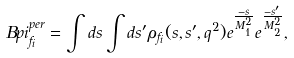<formula> <loc_0><loc_0><loc_500><loc_500>\ B p i _ { f _ { i } } ^ { p e r } = \int d s \int d s ^ { \prime } \rho _ { f _ { i } } ( s , s ^ { \prime } , q ^ { 2 } ) e ^ { \frac { - s } { M _ { 1 } ^ { 2 } } } e ^ { \frac { - s ^ { \prime } } { M _ { 2 } ^ { 2 } } } ,</formula> 